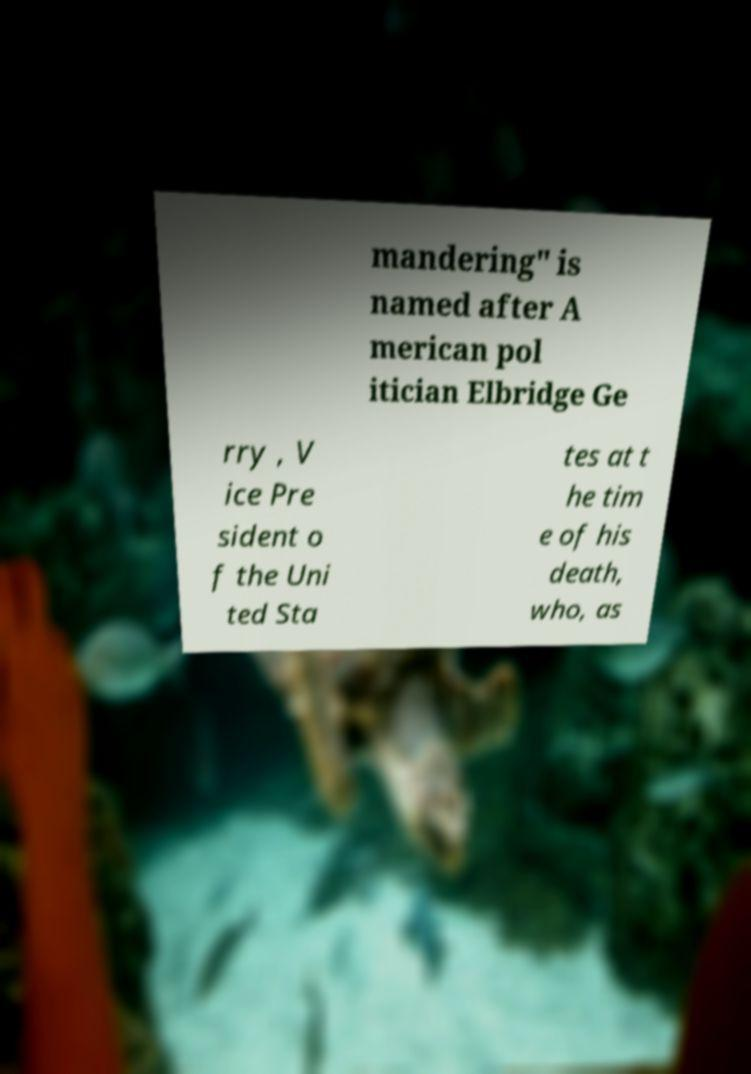What messages or text are displayed in this image? I need them in a readable, typed format. mandering" is named after A merican pol itician Elbridge Ge rry , V ice Pre sident o f the Uni ted Sta tes at t he tim e of his death, who, as 